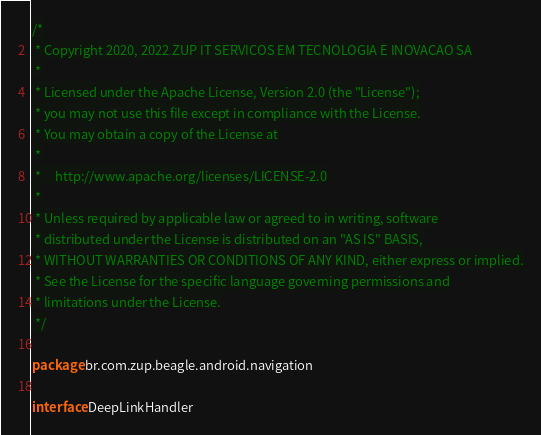Convert code to text. <code><loc_0><loc_0><loc_500><loc_500><_Kotlin_>/*
 * Copyright 2020, 2022 ZUP IT SERVICOS EM TECNOLOGIA E INOVACAO SA
 *
 * Licensed under the Apache License, Version 2.0 (the "License");
 * you may not use this file except in compliance with the License.
 * You may obtain a copy of the License at
 *
 *     http://www.apache.org/licenses/LICENSE-2.0
 *
 * Unless required by applicable law or agreed to in writing, software
 * distributed under the License is distributed on an "AS IS" BASIS,
 * WITHOUT WARRANTIES OR CONDITIONS OF ANY KIND, either express or implied.
 * See the License for the specific language governing permissions and
 * limitations under the License.
 */

package br.com.zup.beagle.android.navigation

interface DeepLinkHandler</code> 